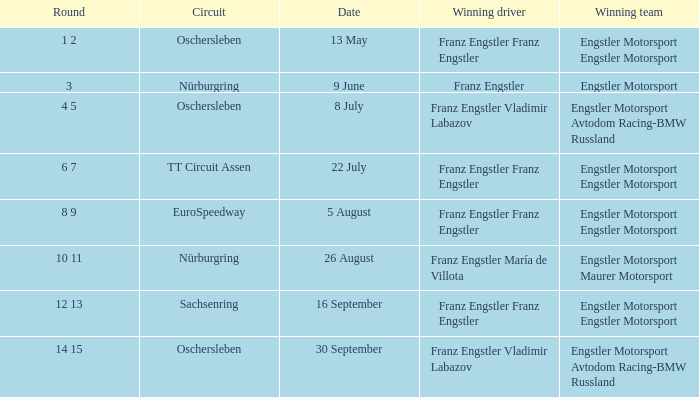Could you help me parse every detail presented in this table? {'header': ['Round', 'Circuit', 'Date', 'Winning driver', 'Winning team'], 'rows': [['1 2', 'Oschersleben', '13 May', 'Franz Engstler Franz Engstler', 'Engstler Motorsport Engstler Motorsport'], ['3', 'Nürburgring', '9 June', 'Franz Engstler', 'Engstler Motorsport'], ['4 5', 'Oschersleben', '8 July', 'Franz Engstler Vladimir Labazov', 'Engstler Motorsport Avtodom Racing-BMW Russland'], ['6 7', 'TT Circuit Assen', '22 July', 'Franz Engstler Franz Engstler', 'Engstler Motorsport Engstler Motorsport'], ['8 9', 'EuroSpeedway', '5 August', 'Franz Engstler Franz Engstler', 'Engstler Motorsport Engstler Motorsport'], ['10 11', 'Nürburgring', '26 August', 'Franz Engstler María de Villota', 'Engstler Motorsport Maurer Motorsport'], ['12 13', 'Sachsenring', '16 September', 'Franz Engstler Franz Engstler', 'Engstler Motorsport Engstler Motorsport'], ['14 15', 'Oschersleben', '30 September', 'Franz Engstler Vladimir Labazov', 'Engstler Motorsport Avtodom Racing-BMW Russland']]} With a Date of 22 July, what is the Winning team? Engstler Motorsport Engstler Motorsport. 